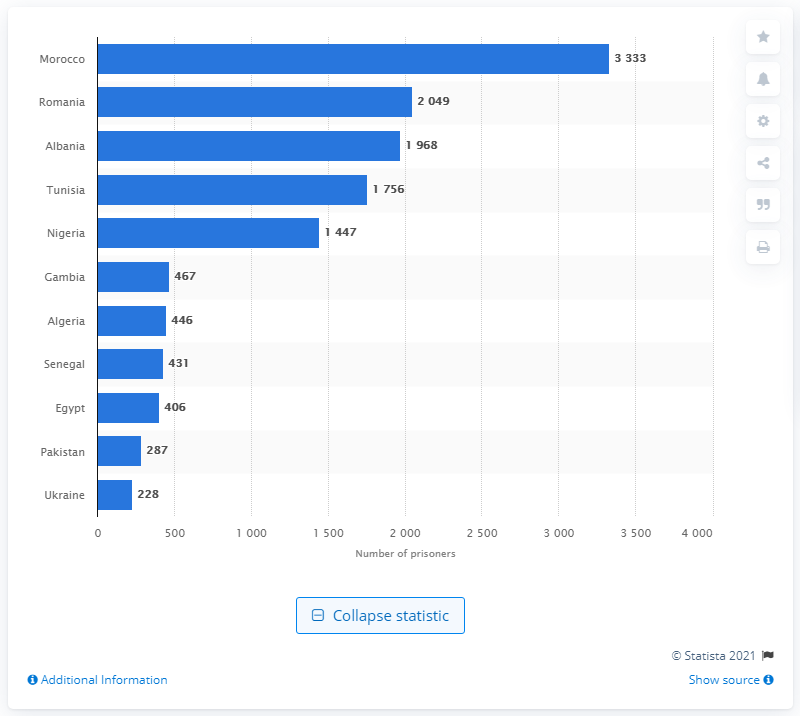Point out several critical features in this image. The country with the largest number of prisoners in 2021 was Morocco. Inmates from Romania were the second largest group of foreign prisoners, according to the data. 